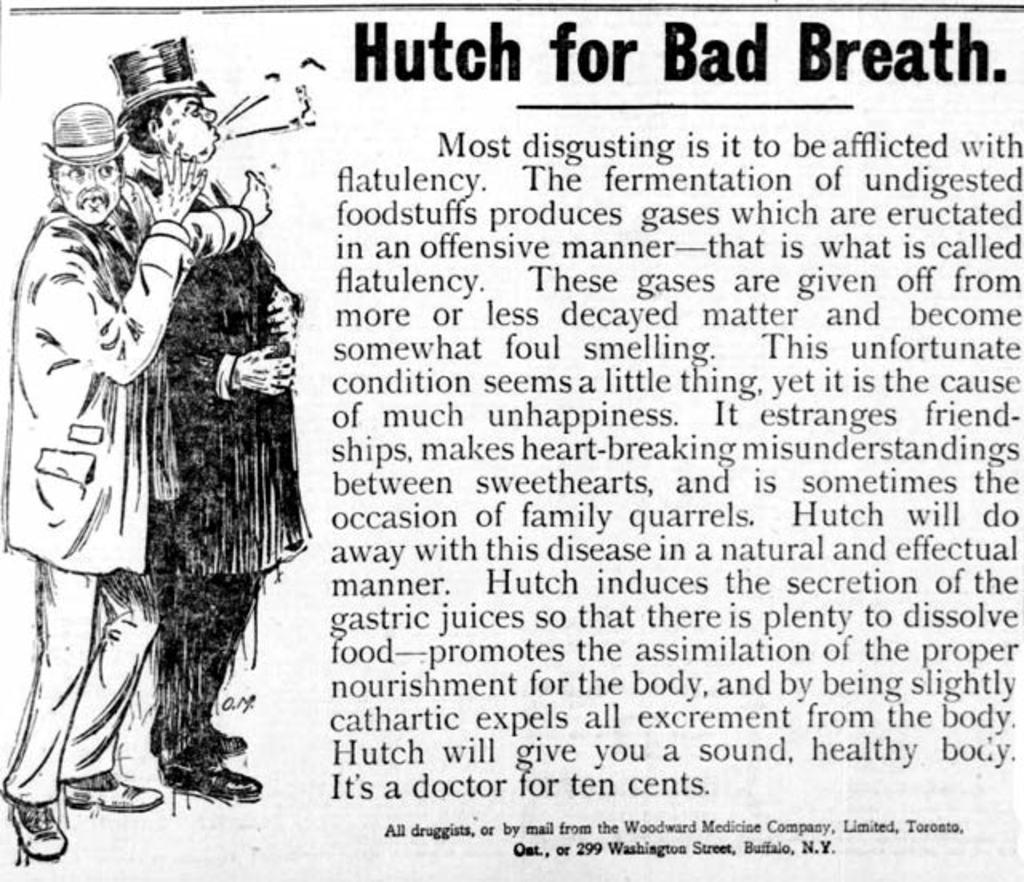What is the main subject of the image? The main subject of the image is a picture. What else can be seen in the image besides the picture? There is text printed on a paper in the image. How many pigs are visible in the image? There are no pigs present in the image. What type of destruction can be seen in the image? There is no destruction present in the image. 